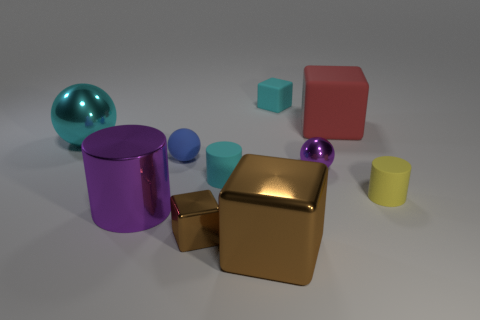How many brown cubes must be subtracted to get 1 brown cubes? 1 Subtract all cylinders. How many objects are left? 7 Subtract 1 blue balls. How many objects are left? 9 Subtract all tiny purple spheres. Subtract all gray matte cylinders. How many objects are left? 9 Add 7 big brown things. How many big brown things are left? 8 Add 1 large blue shiny things. How many large blue shiny things exist? 1 